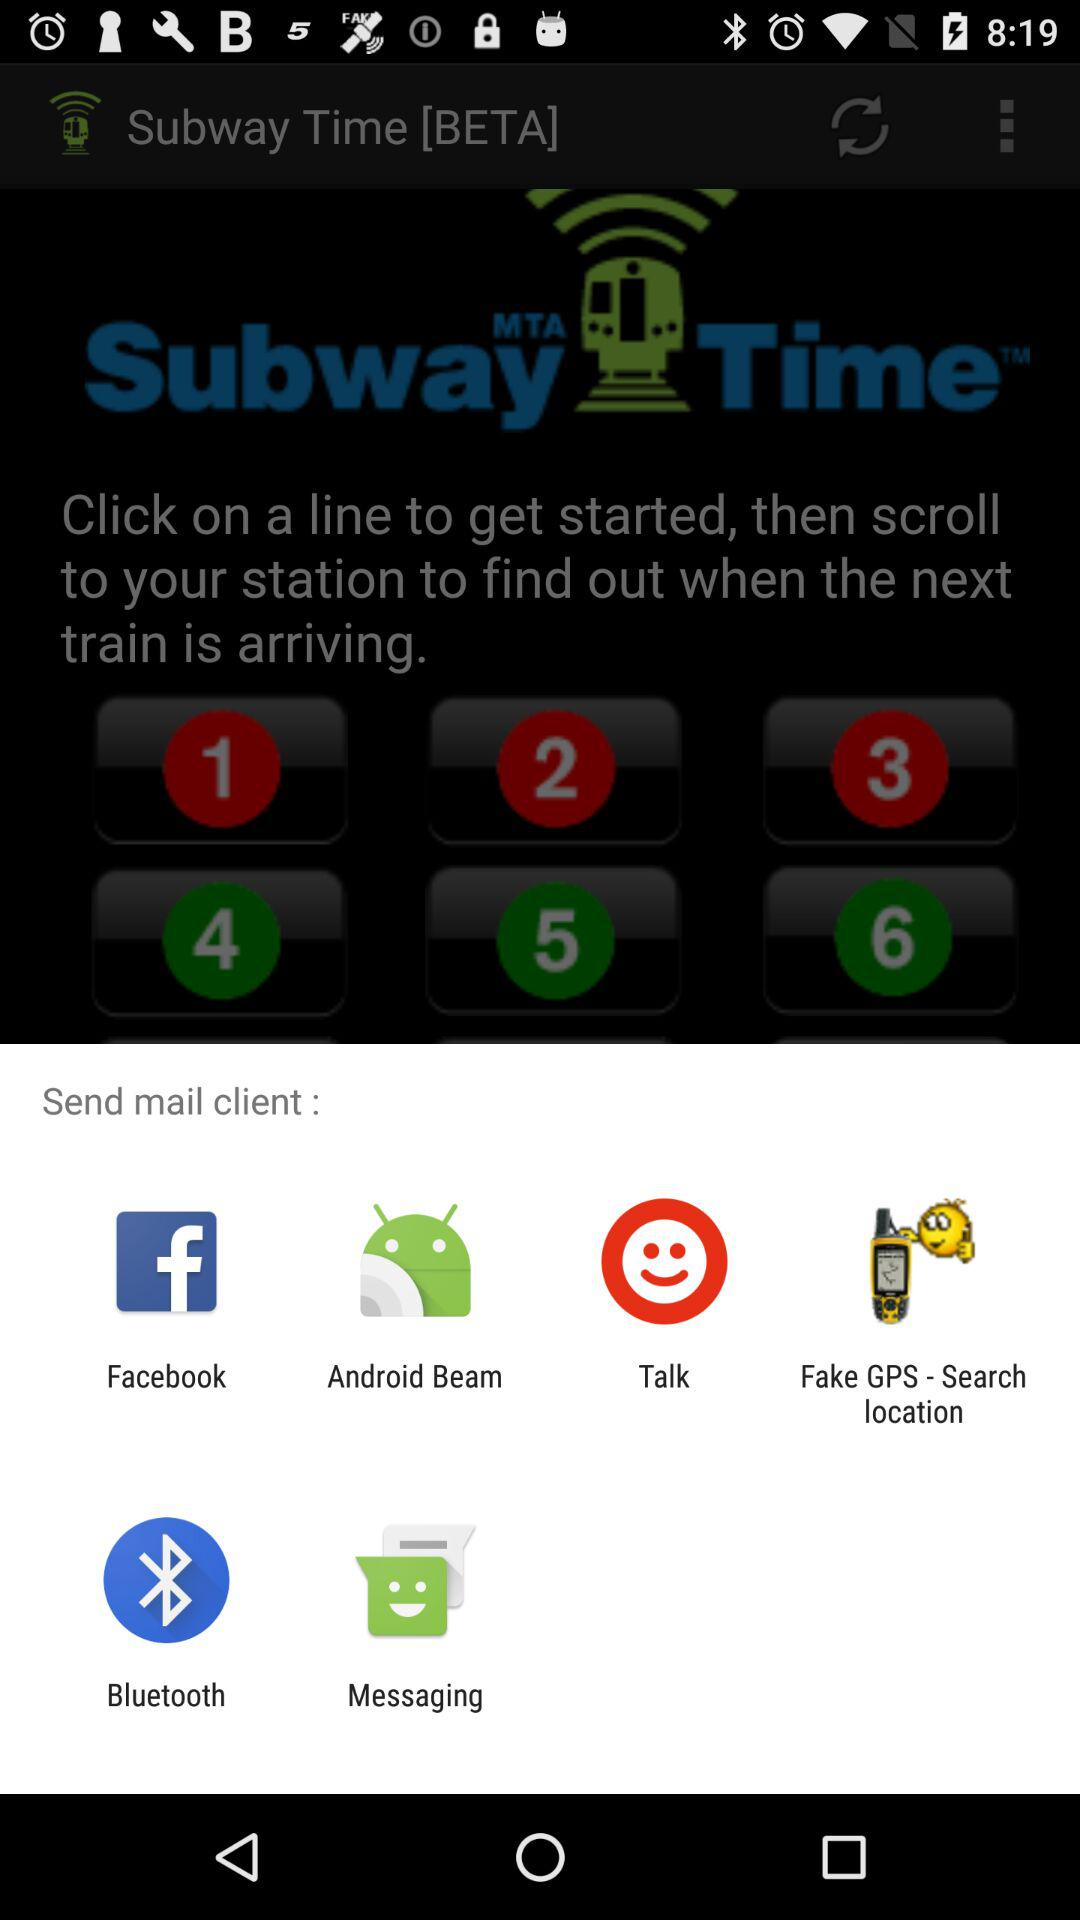How many trains are arriving in less than 10 minutes?
Answer the question using a single word or phrase. 3 